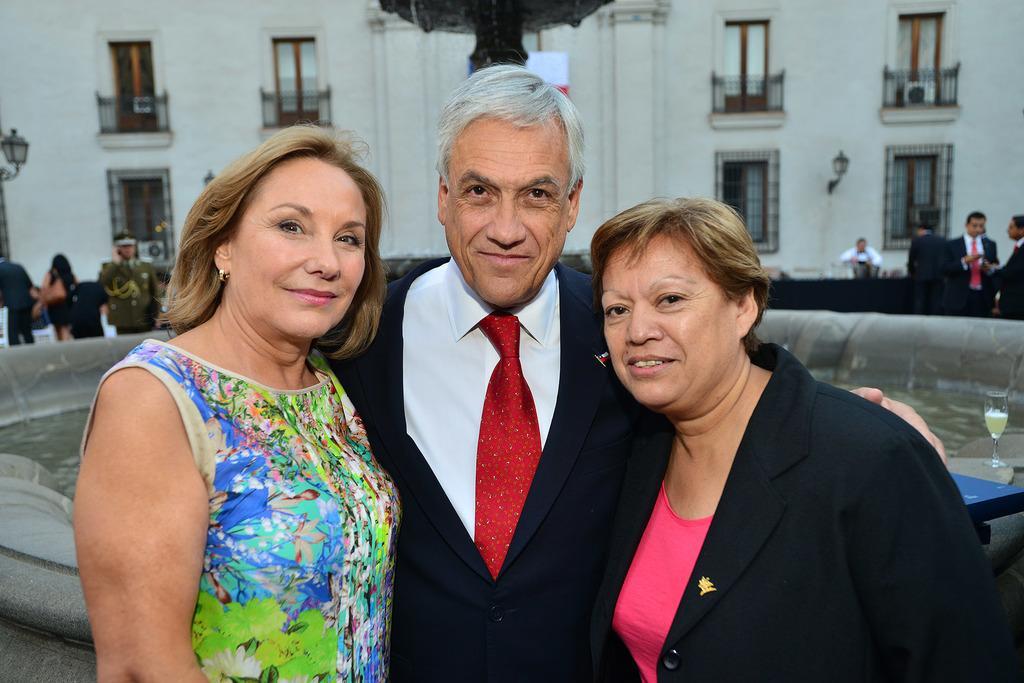Can you describe this image briefly? In this image, in the middle, we can see three people. In the background, we can see a group of people, building, balcony, glass window. In the background, we can also see a fountain, water. On the right side, we can see one edge of a table and a glass with some drink. 